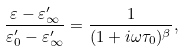Convert formula to latex. <formula><loc_0><loc_0><loc_500><loc_500>\frac { \varepsilon - \varepsilon ^ { \prime } _ { \infty } } { \varepsilon ^ { \prime } _ { 0 } - \varepsilon ^ { \prime } _ { \infty } } = \frac { 1 } { ( 1 + i \omega \tau _ { 0 } ) ^ { \beta } } ,</formula> 